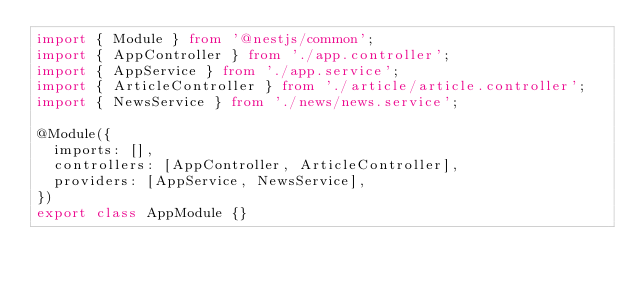Convert code to text. <code><loc_0><loc_0><loc_500><loc_500><_TypeScript_>import { Module } from '@nestjs/common';
import { AppController } from './app.controller';
import { AppService } from './app.service';
import { ArticleController } from './article/article.controller';
import { NewsService } from './news/news.service';

@Module({
  imports: [],
  controllers: [AppController, ArticleController],
  providers: [AppService, NewsService],
})
export class AppModule {}
</code> 